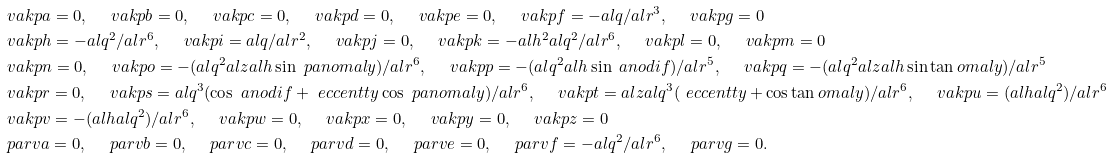Convert formula to latex. <formula><loc_0><loc_0><loc_500><loc_500>& \ v a k p a = 0 , \quad \ v a k p b = 0 , \quad \ v a k p c = 0 , \quad \ v a k p d = 0 , \quad \ v a k p e = 0 , \quad \ v a k p f = - a l q / a l r ^ { 3 } , \quad \ v a k p g = 0 \\ & \ v a k p h = - a l q ^ { 2 } / a l r ^ { 6 } , \quad \ v a k p i = a l q / a l r ^ { 2 } , \quad \ v a k p j = 0 , \quad \ v a k p k = - a l h ^ { 2 } a l q ^ { 2 } / a l r ^ { 6 } , \quad \ v a k p l = 0 , \quad \ v a k p m = 0 \\ & \ v a k p n = 0 , \quad \ v a k p o = - ( a l q ^ { 2 } a l z a l h \sin \ p a n o m a l y ) / a l r ^ { 6 } , \quad \ v a k p p = - ( a l q ^ { 2 } a l h \sin \ a n o d i f ) / a l r ^ { 5 } , \quad \ v a k p q = - ( a l q ^ { 2 } a l z a l h \sin \tan o m a l y ) / a l r ^ { 5 } \\ & \ v a k p r = 0 , \quad \ v a k p s = a l q ^ { 3 } ( \cos \ a n o d i f + \ e c c e n t t y \cos \ p a n o m a l y ) / a l r ^ { 6 } , \quad \ v a k p t = a l z a l q ^ { 3 } ( \ e c c e n t t y + \cos \tan o m a l y ) / a l r ^ { 6 } , \quad \ v a k p u = ( a l h a l q ^ { 2 } ) / a l r ^ { 6 } \\ & \ v a k p v = - ( a l h a l q ^ { 2 } ) / a l r ^ { 6 } , \quad \ v a k p w = 0 , \quad \ v a k p x = 0 , \quad \ v a k p y = 0 , \quad \ v a k p z = 0 \\ & \ p a r v a = 0 , \quad \ p a r v b = 0 , \quad \ p a r v c = 0 , \quad \ p a r v d = 0 , \quad \ p a r v e = 0 , \quad \ p a r v f = - a l q ^ { 2 } / a l r ^ { 6 } , \quad \ p a r v g = 0 .</formula> 